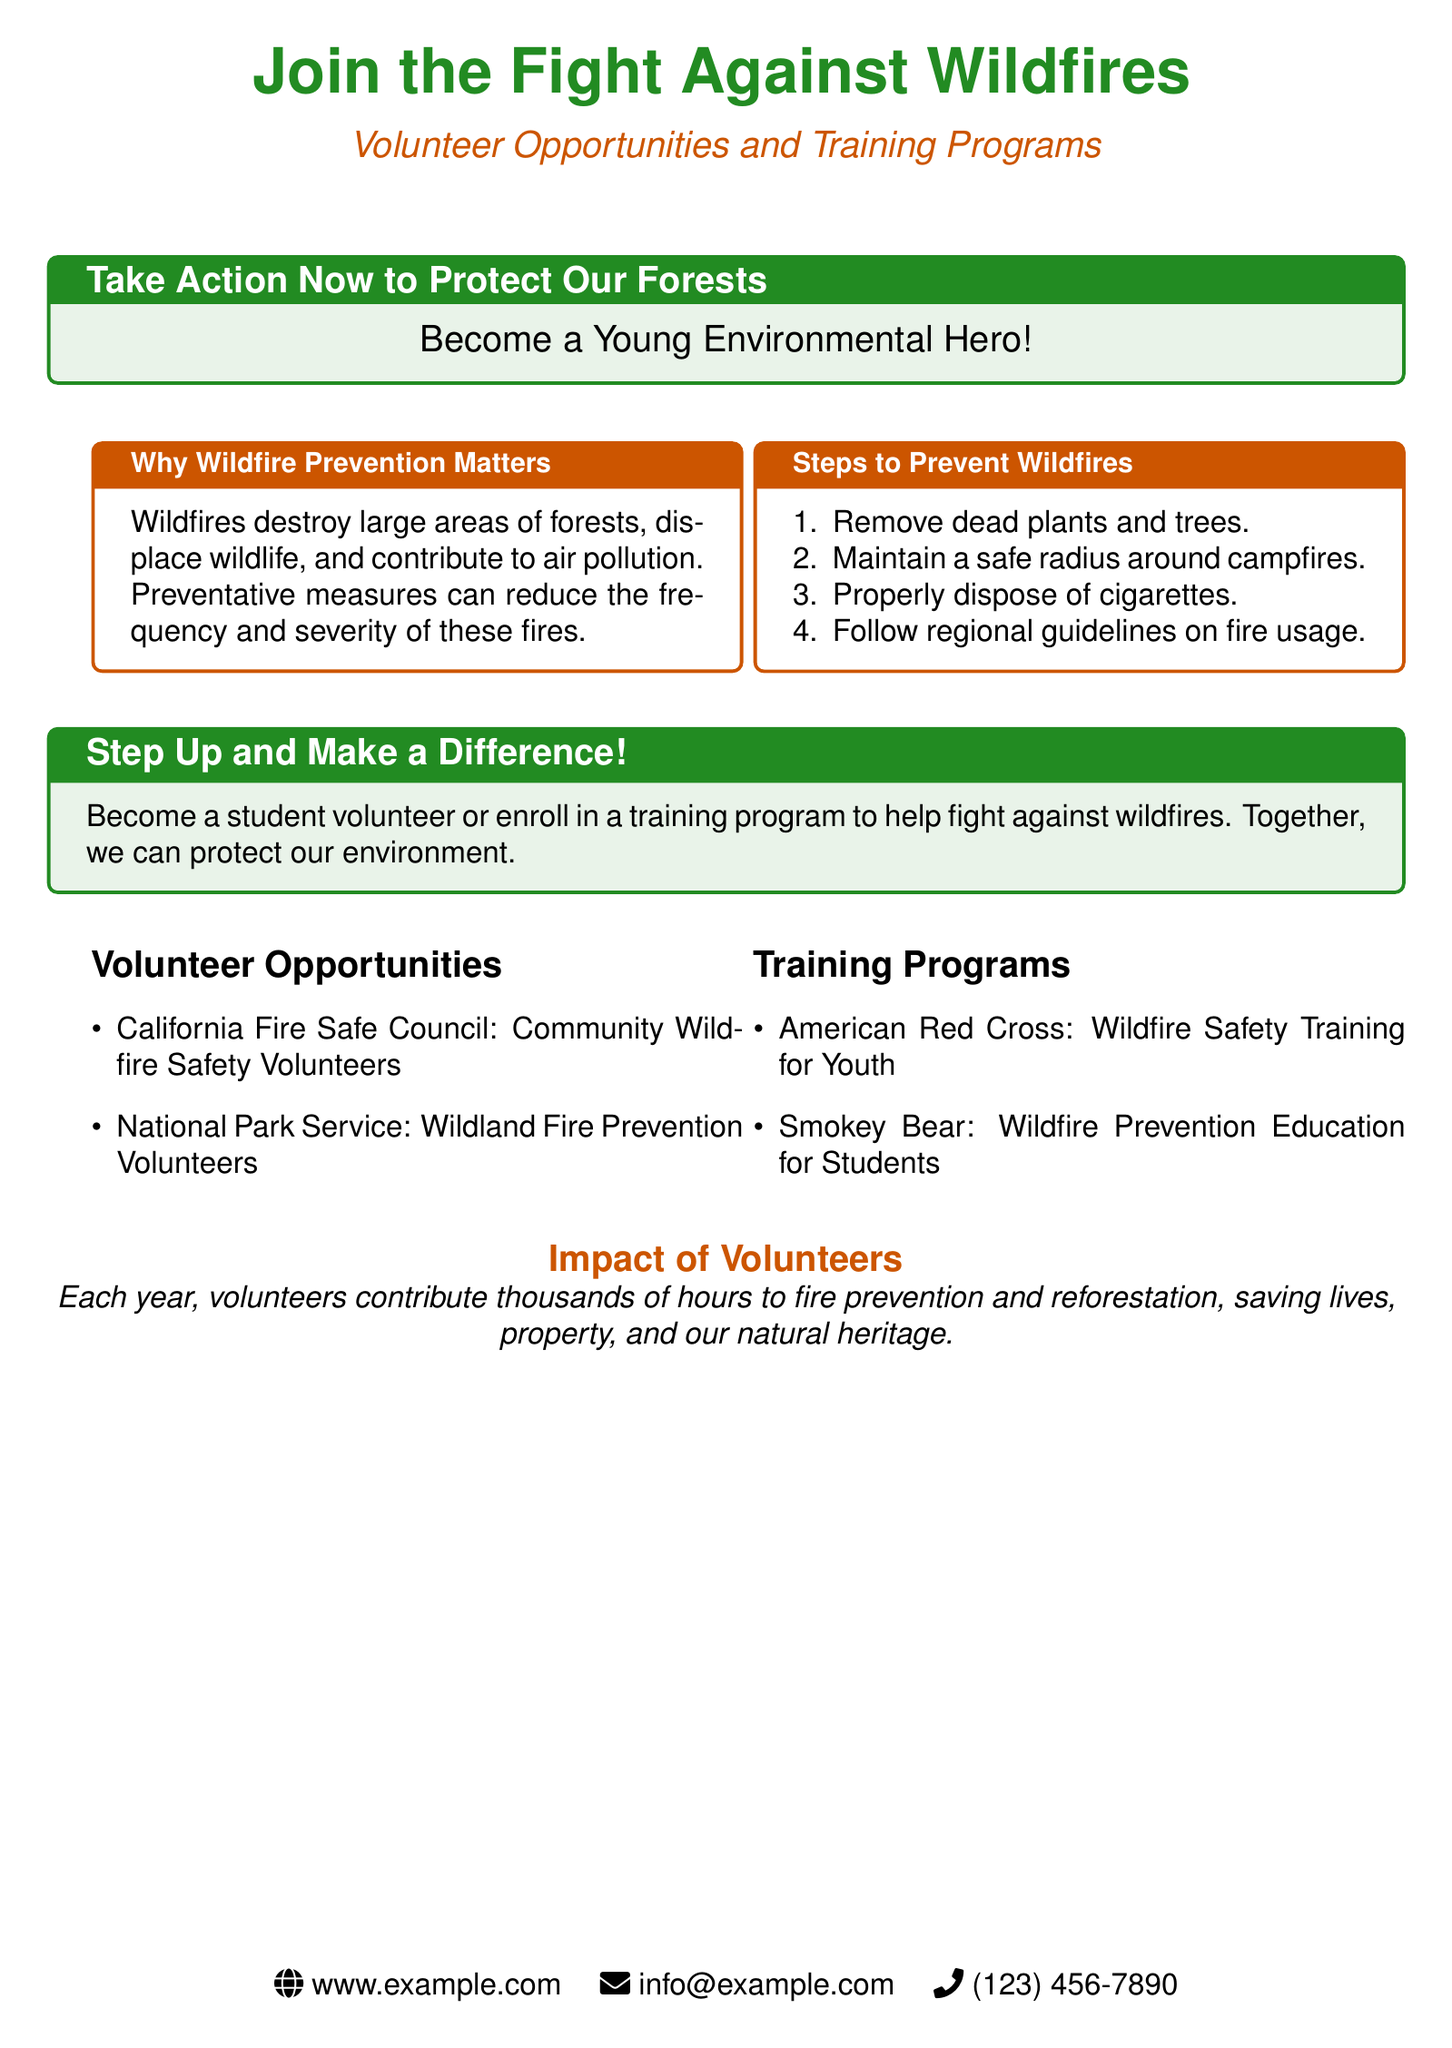What opportunities are there for volunteering? The document lists two main volunteer opportunities: California Fire Safe Council and National Park Service.
Answer: California Fire Safe Council and National Park Service What is the goal of wildfire prevention? The document specifies that wildfires destroy forests, displace wildlife, and contribute to air pollution, and that preventative measures can help reduce these issues.
Answer: To reduce wildfires How many training programs are mentioned? The document lists two specific training programs for youth regarding wildfire prevention.
Answer: Two What is one step to prevent wildfires? The document outlines several steps; one of them is to remove dead plants and trees.
Answer: Remove dead plants and trees Why should students join the fight against wildfires? The document encourages students by stating that together, we can protect our environment.
Answer: To protect our environment What type of training does the American Red Cross provide? It specifically offers wildfire safety training tailored for youth.
Answer: Wildfire Safety Training for Youth How does the document describe the impact of volunteers? It states that volunteers contribute thousands of hours to fire prevention and save lives, property, and natural heritage.
Answer: Thousands of hours What color is used for the title "Join the Fight Against Wildfires"? The document uses a shade of forest green for the title.
Answer: Forest green 